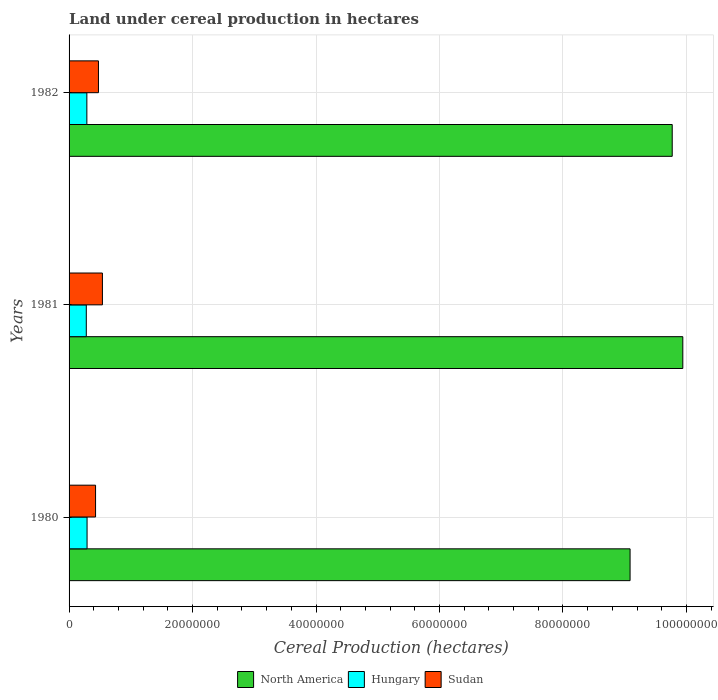Are the number of bars on each tick of the Y-axis equal?
Offer a terse response. Yes. What is the label of the 1st group of bars from the top?
Provide a short and direct response. 1982. What is the land under cereal production in Sudan in 1981?
Your answer should be compact. 5.40e+06. Across all years, what is the maximum land under cereal production in Hungary?
Provide a short and direct response. 2.91e+06. Across all years, what is the minimum land under cereal production in Hungary?
Make the answer very short. 2.79e+06. In which year was the land under cereal production in North America maximum?
Your answer should be compact. 1981. In which year was the land under cereal production in Sudan minimum?
Your answer should be very brief. 1980. What is the total land under cereal production in North America in the graph?
Provide a succinct answer. 2.88e+08. What is the difference between the land under cereal production in Hungary in 1980 and that in 1981?
Your response must be concise. 1.25e+05. What is the difference between the land under cereal production in North America in 1980 and the land under cereal production in Hungary in 1982?
Ensure brevity in your answer.  8.80e+07. What is the average land under cereal production in Sudan per year?
Provide a short and direct response. 4.82e+06. In the year 1981, what is the difference between the land under cereal production in Sudan and land under cereal production in North America?
Ensure brevity in your answer.  -9.40e+07. In how many years, is the land under cereal production in Sudan greater than 44000000 hectares?
Your response must be concise. 0. What is the ratio of the land under cereal production in Sudan in 1981 to that in 1982?
Your response must be concise. 1.13. Is the land under cereal production in Sudan in 1981 less than that in 1982?
Your answer should be very brief. No. What is the difference between the highest and the second highest land under cereal production in North America?
Give a very brief answer. 1.71e+06. What is the difference between the highest and the lowest land under cereal production in Hungary?
Keep it short and to the point. 1.25e+05. In how many years, is the land under cereal production in Sudan greater than the average land under cereal production in Sudan taken over all years?
Your response must be concise. 1. What does the 2nd bar from the top in 1980 represents?
Provide a short and direct response. Hungary. What does the 2nd bar from the bottom in 1982 represents?
Provide a short and direct response. Hungary. Are all the bars in the graph horizontal?
Your answer should be very brief. Yes. What is the difference between two consecutive major ticks on the X-axis?
Your answer should be very brief. 2.00e+07. Are the values on the major ticks of X-axis written in scientific E-notation?
Ensure brevity in your answer.  No. How are the legend labels stacked?
Your response must be concise. Horizontal. What is the title of the graph?
Your answer should be compact. Land under cereal production in hectares. What is the label or title of the X-axis?
Ensure brevity in your answer.  Cereal Production (hectares). What is the label or title of the Y-axis?
Your response must be concise. Years. What is the Cereal Production (hectares) in North America in 1980?
Ensure brevity in your answer.  9.09e+07. What is the Cereal Production (hectares) in Hungary in 1980?
Give a very brief answer. 2.91e+06. What is the Cereal Production (hectares) in Sudan in 1980?
Provide a short and direct response. 4.29e+06. What is the Cereal Production (hectares) in North America in 1981?
Ensure brevity in your answer.  9.94e+07. What is the Cereal Production (hectares) in Hungary in 1981?
Ensure brevity in your answer.  2.79e+06. What is the Cereal Production (hectares) of Sudan in 1981?
Your answer should be compact. 5.40e+06. What is the Cereal Production (hectares) in North America in 1982?
Give a very brief answer. 9.77e+07. What is the Cereal Production (hectares) of Hungary in 1982?
Give a very brief answer. 2.88e+06. What is the Cereal Production (hectares) in Sudan in 1982?
Provide a succinct answer. 4.76e+06. Across all years, what is the maximum Cereal Production (hectares) of North America?
Your response must be concise. 9.94e+07. Across all years, what is the maximum Cereal Production (hectares) in Hungary?
Give a very brief answer. 2.91e+06. Across all years, what is the maximum Cereal Production (hectares) in Sudan?
Provide a succinct answer. 5.40e+06. Across all years, what is the minimum Cereal Production (hectares) of North America?
Provide a short and direct response. 9.09e+07. Across all years, what is the minimum Cereal Production (hectares) of Hungary?
Give a very brief answer. 2.79e+06. Across all years, what is the minimum Cereal Production (hectares) in Sudan?
Ensure brevity in your answer.  4.29e+06. What is the total Cereal Production (hectares) in North America in the graph?
Make the answer very short. 2.88e+08. What is the total Cereal Production (hectares) of Hungary in the graph?
Keep it short and to the point. 8.59e+06. What is the total Cereal Production (hectares) of Sudan in the graph?
Provide a succinct answer. 1.45e+07. What is the difference between the Cereal Production (hectares) of North America in 1980 and that in 1981?
Give a very brief answer. -8.54e+06. What is the difference between the Cereal Production (hectares) of Hungary in 1980 and that in 1981?
Your response must be concise. 1.25e+05. What is the difference between the Cereal Production (hectares) of Sudan in 1980 and that in 1981?
Offer a very short reply. -1.11e+06. What is the difference between the Cereal Production (hectares) of North America in 1980 and that in 1982?
Your answer should be very brief. -6.83e+06. What is the difference between the Cereal Production (hectares) of Hungary in 1980 and that in 1982?
Provide a succinct answer. 3.36e+04. What is the difference between the Cereal Production (hectares) in Sudan in 1980 and that in 1982?
Keep it short and to the point. -4.69e+05. What is the difference between the Cereal Production (hectares) of North America in 1981 and that in 1982?
Make the answer very short. 1.71e+06. What is the difference between the Cereal Production (hectares) in Hungary in 1981 and that in 1982?
Your answer should be very brief. -9.11e+04. What is the difference between the Cereal Production (hectares) of Sudan in 1981 and that in 1982?
Offer a terse response. 6.41e+05. What is the difference between the Cereal Production (hectares) of North America in 1980 and the Cereal Production (hectares) of Hungary in 1981?
Ensure brevity in your answer.  8.81e+07. What is the difference between the Cereal Production (hectares) in North America in 1980 and the Cereal Production (hectares) in Sudan in 1981?
Your answer should be compact. 8.55e+07. What is the difference between the Cereal Production (hectares) of Hungary in 1980 and the Cereal Production (hectares) of Sudan in 1981?
Your answer should be very brief. -2.49e+06. What is the difference between the Cereal Production (hectares) of North America in 1980 and the Cereal Production (hectares) of Hungary in 1982?
Offer a very short reply. 8.80e+07. What is the difference between the Cereal Production (hectares) in North America in 1980 and the Cereal Production (hectares) in Sudan in 1982?
Provide a succinct answer. 8.61e+07. What is the difference between the Cereal Production (hectares) of Hungary in 1980 and the Cereal Production (hectares) of Sudan in 1982?
Ensure brevity in your answer.  -1.84e+06. What is the difference between the Cereal Production (hectares) of North America in 1981 and the Cereal Production (hectares) of Hungary in 1982?
Make the answer very short. 9.65e+07. What is the difference between the Cereal Production (hectares) of North America in 1981 and the Cereal Production (hectares) of Sudan in 1982?
Provide a succinct answer. 9.47e+07. What is the difference between the Cereal Production (hectares) of Hungary in 1981 and the Cereal Production (hectares) of Sudan in 1982?
Offer a terse response. -1.97e+06. What is the average Cereal Production (hectares) of North America per year?
Make the answer very short. 9.60e+07. What is the average Cereal Production (hectares) in Hungary per year?
Provide a succinct answer. 2.86e+06. What is the average Cereal Production (hectares) in Sudan per year?
Make the answer very short. 4.82e+06. In the year 1980, what is the difference between the Cereal Production (hectares) in North America and Cereal Production (hectares) in Hungary?
Ensure brevity in your answer.  8.80e+07. In the year 1980, what is the difference between the Cereal Production (hectares) of North America and Cereal Production (hectares) of Sudan?
Give a very brief answer. 8.66e+07. In the year 1980, what is the difference between the Cereal Production (hectares) in Hungary and Cereal Production (hectares) in Sudan?
Your answer should be compact. -1.38e+06. In the year 1981, what is the difference between the Cereal Production (hectares) in North America and Cereal Production (hectares) in Hungary?
Keep it short and to the point. 9.66e+07. In the year 1981, what is the difference between the Cereal Production (hectares) in North America and Cereal Production (hectares) in Sudan?
Offer a terse response. 9.40e+07. In the year 1981, what is the difference between the Cereal Production (hectares) of Hungary and Cereal Production (hectares) of Sudan?
Provide a succinct answer. -2.61e+06. In the year 1982, what is the difference between the Cereal Production (hectares) in North America and Cereal Production (hectares) in Hungary?
Give a very brief answer. 9.48e+07. In the year 1982, what is the difference between the Cereal Production (hectares) in North America and Cereal Production (hectares) in Sudan?
Your answer should be compact. 9.29e+07. In the year 1982, what is the difference between the Cereal Production (hectares) of Hungary and Cereal Production (hectares) of Sudan?
Your answer should be very brief. -1.88e+06. What is the ratio of the Cereal Production (hectares) in North America in 1980 to that in 1981?
Provide a succinct answer. 0.91. What is the ratio of the Cereal Production (hectares) of Hungary in 1980 to that in 1981?
Provide a succinct answer. 1.04. What is the ratio of the Cereal Production (hectares) of Sudan in 1980 to that in 1981?
Your answer should be compact. 0.79. What is the ratio of the Cereal Production (hectares) of North America in 1980 to that in 1982?
Give a very brief answer. 0.93. What is the ratio of the Cereal Production (hectares) of Hungary in 1980 to that in 1982?
Provide a succinct answer. 1.01. What is the ratio of the Cereal Production (hectares) of Sudan in 1980 to that in 1982?
Your response must be concise. 0.9. What is the ratio of the Cereal Production (hectares) in North America in 1981 to that in 1982?
Offer a terse response. 1.02. What is the ratio of the Cereal Production (hectares) in Hungary in 1981 to that in 1982?
Keep it short and to the point. 0.97. What is the ratio of the Cereal Production (hectares) of Sudan in 1981 to that in 1982?
Your answer should be very brief. 1.13. What is the difference between the highest and the second highest Cereal Production (hectares) of North America?
Keep it short and to the point. 1.71e+06. What is the difference between the highest and the second highest Cereal Production (hectares) in Hungary?
Offer a very short reply. 3.36e+04. What is the difference between the highest and the second highest Cereal Production (hectares) of Sudan?
Your answer should be compact. 6.41e+05. What is the difference between the highest and the lowest Cereal Production (hectares) in North America?
Your answer should be compact. 8.54e+06. What is the difference between the highest and the lowest Cereal Production (hectares) of Hungary?
Provide a short and direct response. 1.25e+05. What is the difference between the highest and the lowest Cereal Production (hectares) in Sudan?
Offer a terse response. 1.11e+06. 